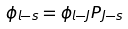Convert formula to latex. <formula><loc_0><loc_0><loc_500><loc_500>\phi _ { l - s } = \phi _ { l - J } P _ { J - s }</formula> 